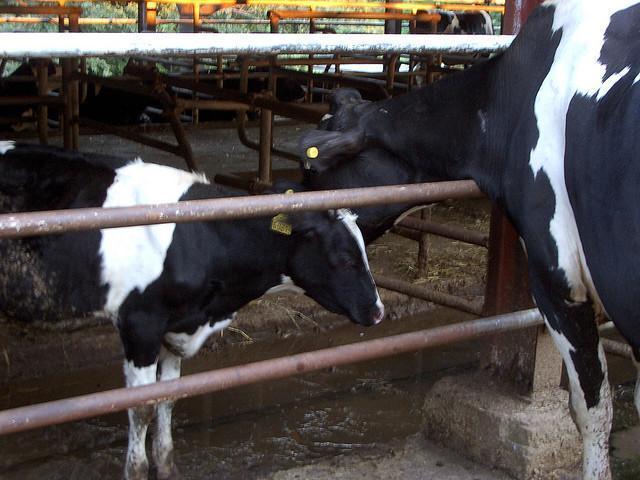How many cows are in the photo?
Give a very brief answer. 2. How many bikes are here?
Give a very brief answer. 0. 